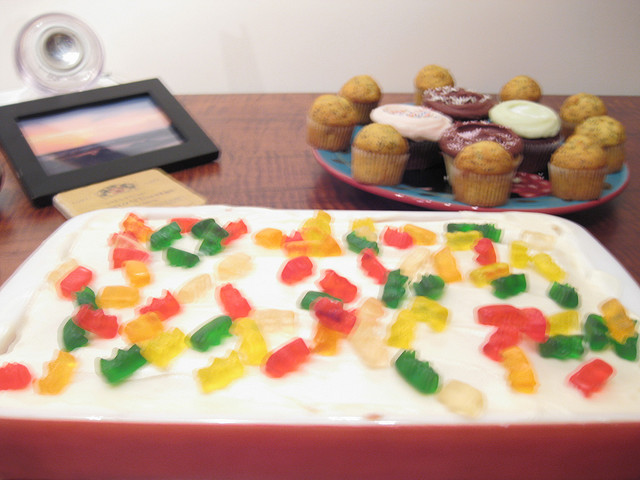<image>What animal head is on the plate? I am unsure about what animal head is on the plate. It could be a bear or a horse. What animal head is on the plate? I don't know which animal head is on the plate. It is either a bear or a horse. 